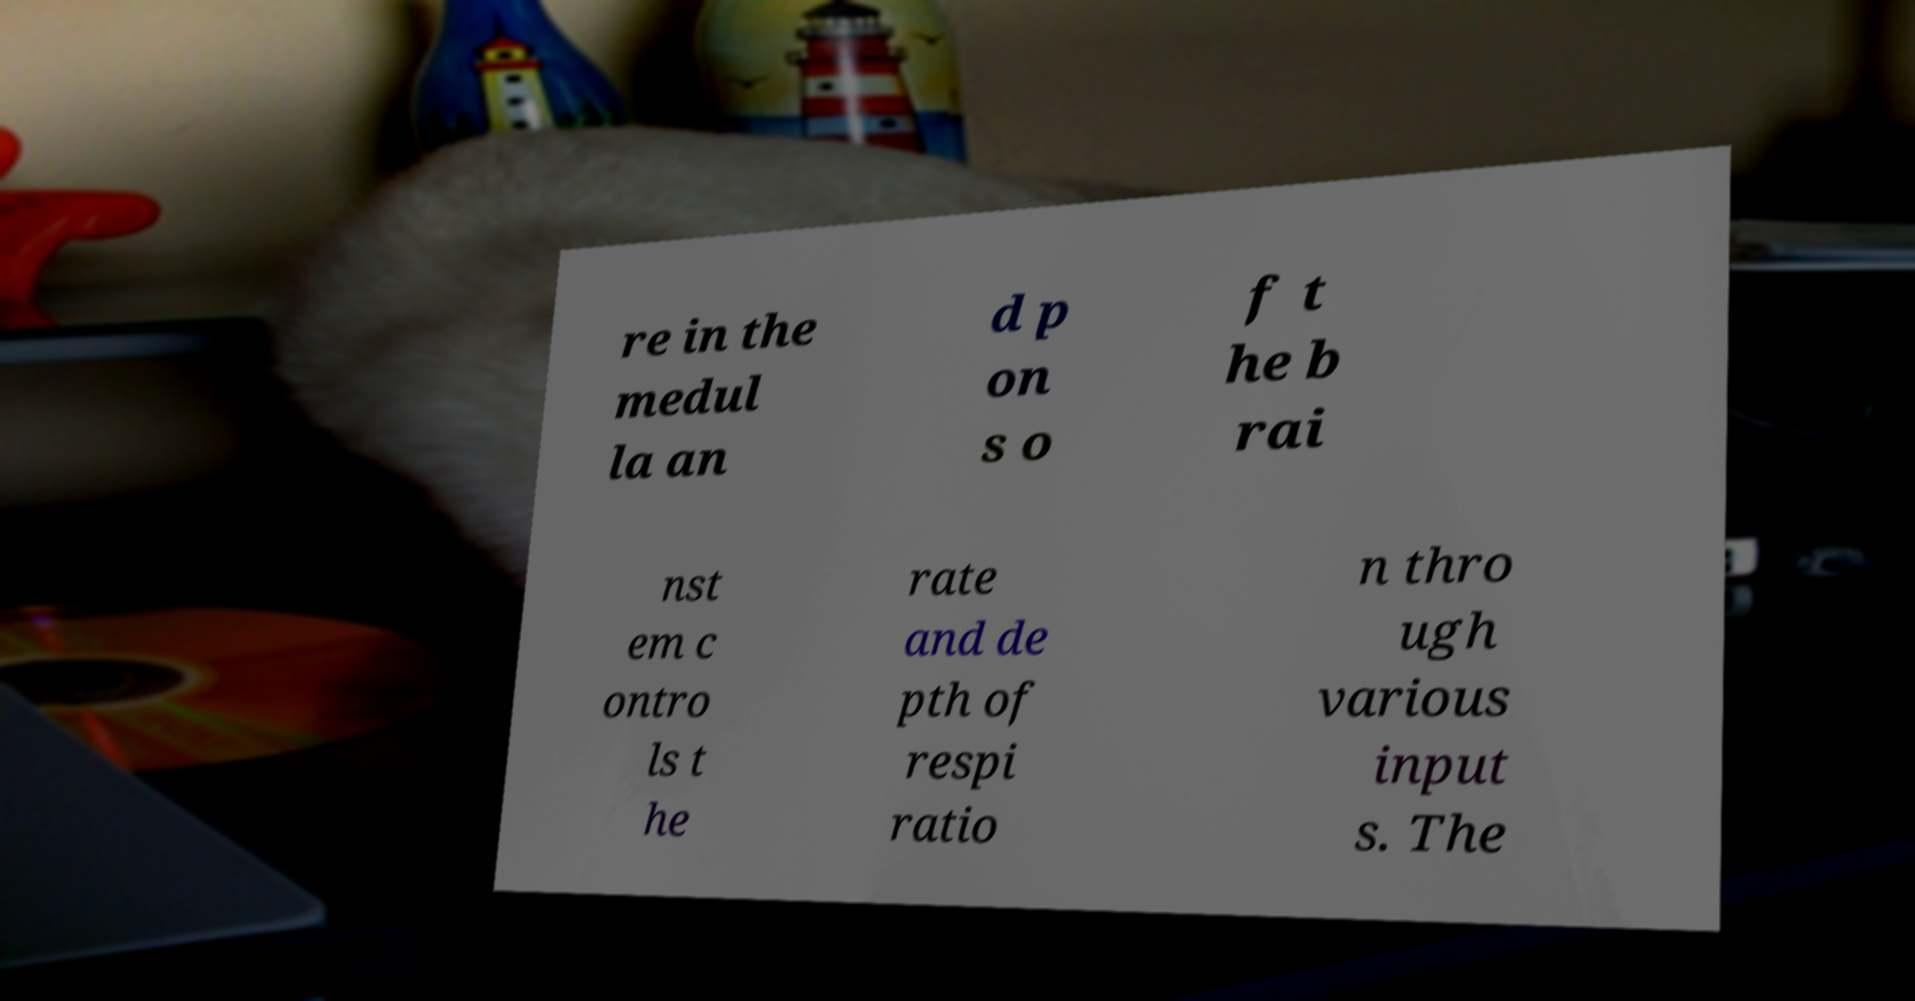Could you extract and type out the text from this image? re in the medul la an d p on s o f t he b rai nst em c ontro ls t he rate and de pth of respi ratio n thro ugh various input s. The 